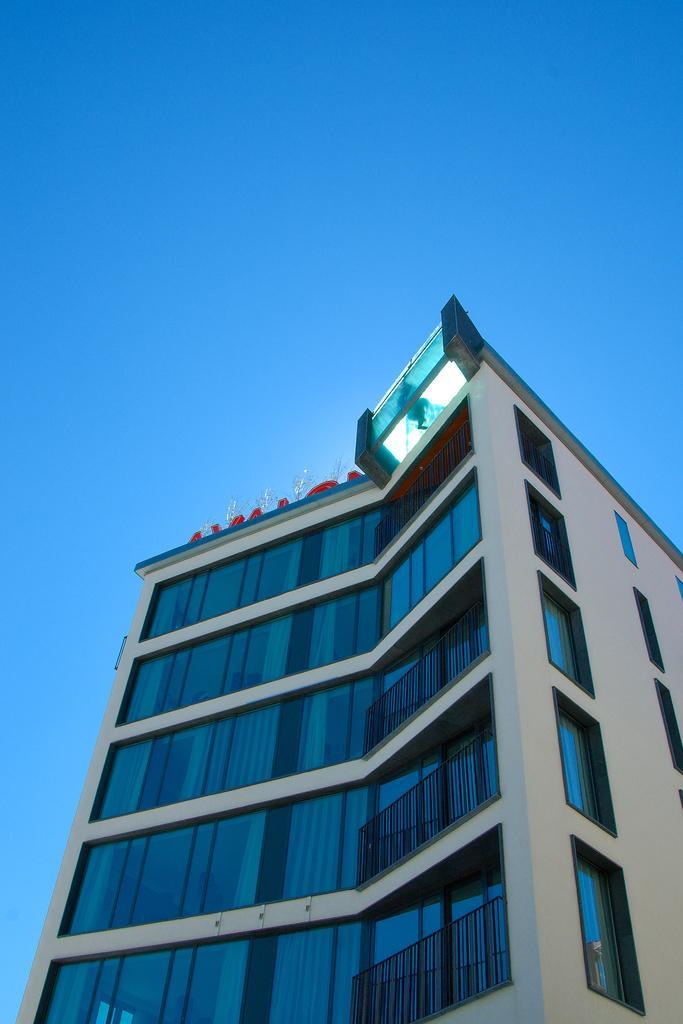In one or two sentences, can you explain what this image depicts? In this image, we can see a building. We can also see some objects on the top of the building. We can also see the sky. 